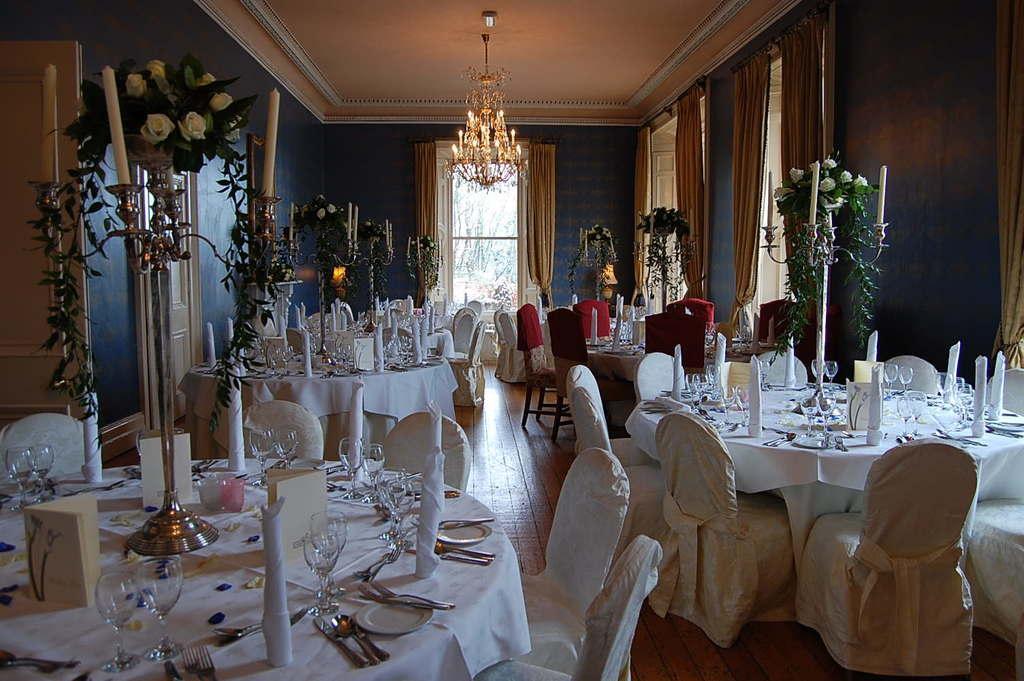Please provide a concise description of this image. In the image there are tables with plates, glasses, spoons, forks, stand with candles and flower bouquets, cards and some other things. And also there are chairs. In the background there is a wall with windows, curtains and doors. At the top of the image there is a chandelier. 